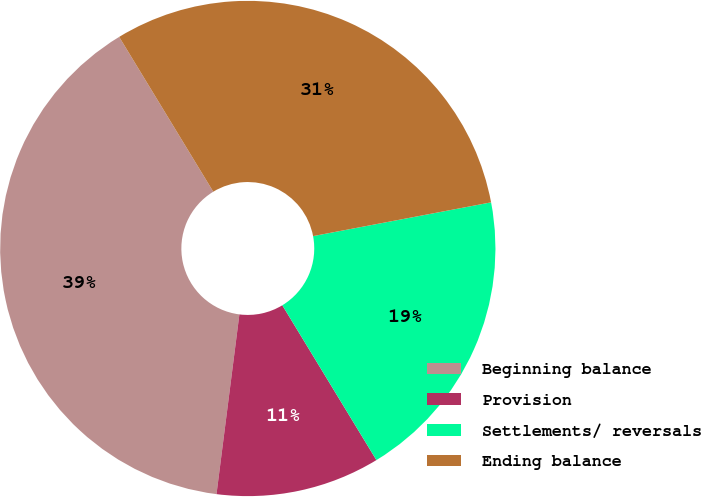Convert chart to OTSL. <chart><loc_0><loc_0><loc_500><loc_500><pie_chart><fcel>Beginning balance<fcel>Provision<fcel>Settlements/ reversals<fcel>Ending balance<nl><fcel>39.29%<fcel>10.71%<fcel>19.29%<fcel>30.71%<nl></chart> 